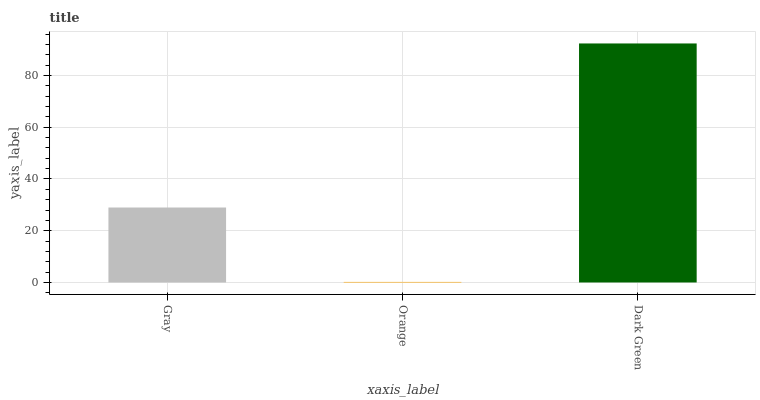Is Orange the minimum?
Answer yes or no. Yes. Is Dark Green the maximum?
Answer yes or no. Yes. Is Dark Green the minimum?
Answer yes or no. No. Is Orange the maximum?
Answer yes or no. No. Is Dark Green greater than Orange?
Answer yes or no. Yes. Is Orange less than Dark Green?
Answer yes or no. Yes. Is Orange greater than Dark Green?
Answer yes or no. No. Is Dark Green less than Orange?
Answer yes or no. No. Is Gray the high median?
Answer yes or no. Yes. Is Gray the low median?
Answer yes or no. Yes. Is Orange the high median?
Answer yes or no. No. Is Orange the low median?
Answer yes or no. No. 